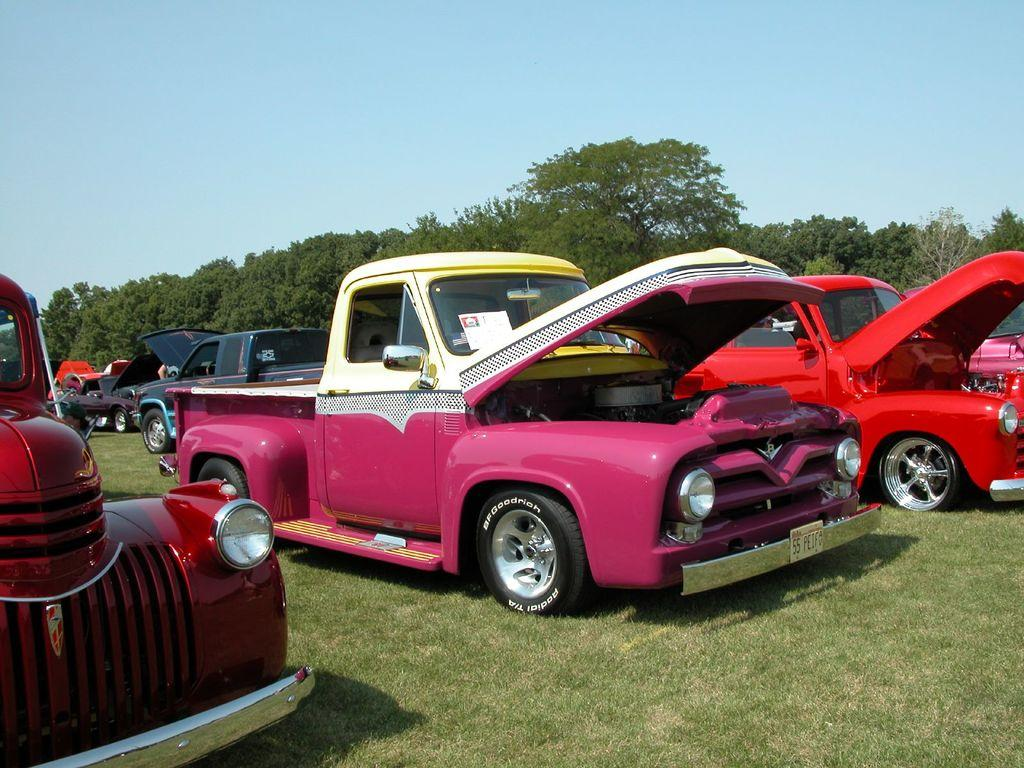What type of vehicles are in the image? There are colorful cars in the image. Where are the cars located? The cars are parked on the grass. What can be seen in the background of the image? There are trees visible in the background of the image. Reasoning: Let' Let's think step by step in order to produce the conversation. We start by identifying the main subject in the image, which is the colorful cars. Then, we describe their location, which is on the grass. Finally, we mention the background of the image, which includes trees. Each question is designed to elicit a specific detail about the image that is known from the provided facts. Absurd Question/Answer: What type of door can be seen on the cars in the image? There is no door visible on the cars in the image; only the cars themselves are visible. 